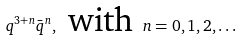<formula> <loc_0><loc_0><loc_500><loc_500>q ^ { 3 + n } \bar { q } ^ { n } , \text { with } n = 0 , 1 , 2 , \dots</formula> 